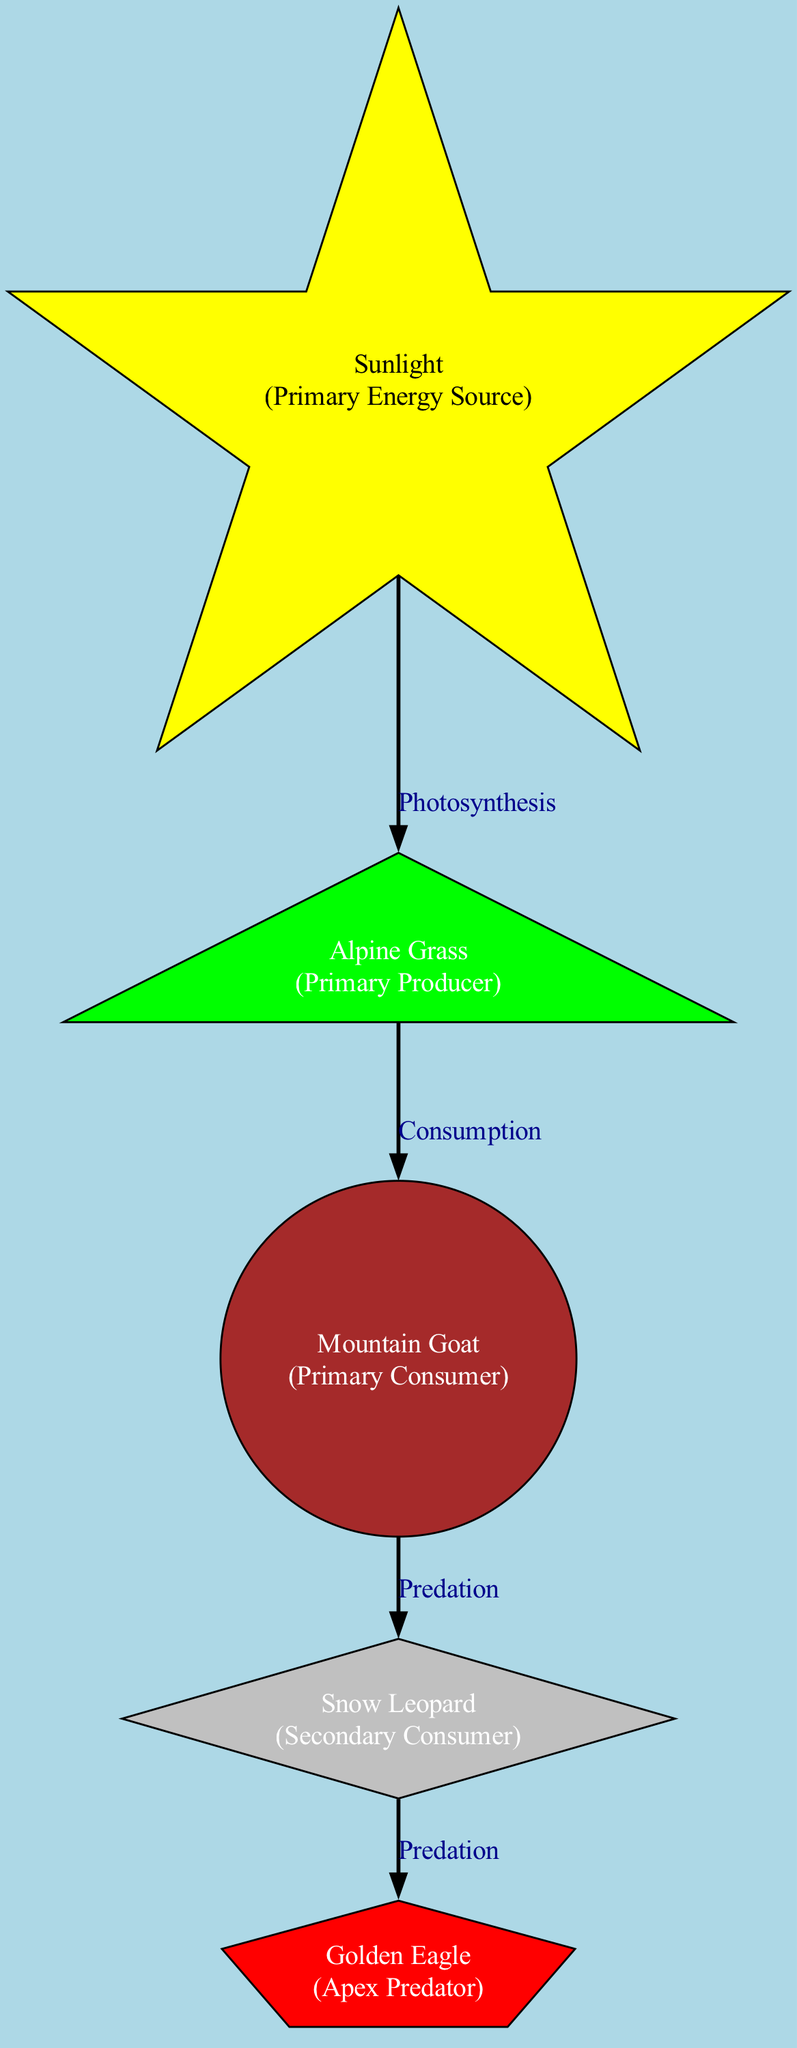What is the primary energy source in the diagram? The diagram starts with the node 'sunlight', which is described as the primary energy source. This is the first node listed in the data and directs towards the producers.
Answer: Sunlight How many nodes are present in the food chain? The food chain has five distinct nodes: 'sunlight', 'alpine_grass', 'alpine_herbivore', 'alpine_carnivore', and 'apex_predator'. By counting each node listed in the data, we confirm a total of five.
Answer: 5 What type of organism is the 'Mountain Goat' in the energy flow? 'Mountain Goat' is classified as a primary consumer in the hierarchy of the food chain based on its position after the producers and before the carnivores.
Answer: Primary Consumer What relationship is indicated by the edge connecting 'Alpine Grass' to 'Mountain Goat'? The edge between 'alpine_grass' and 'alpine_herbivore' is labeled 'Consumption', showing the relationship of the goat consuming grass, which represents the flow of energy in that direction.
Answer: Consumption Which organism is at the top of the food chain? The apex predator at the top of the food chain is represented by the 'Golden Eagle' node, which is the last in the flow of energy relationships.
Answer: Golden Eagle How many edges are present in the diagram? A count of the edges connecting the nodes shows four connections: sunlight to alpine_grass, alpine_grass to alpine_herbivore, alpine_herbivore to alpine_carnivore, and alpine_carnivore to apex_predator.
Answer: 4 What does the arrow from 'Alpine Carnivore' to 'Apex Predator' indicate? This arrow represents the relationship of 'Predation', indicating that the 'alpine_carnivore', like the snow leopard, preys on the apex predator, which is the golden eagle in this context.
Answer: Predation Which node represents a primary producer? The 'Alpine Grass' node is defined as the primary producer in the food chain, being the first level that captures energy from sunlight.
Answer: Alpine Grass What energy transfer process is occurring from 'Sunlight' to 'Alpine Grass'? The process of 'Photosynthesis' is indicated here, where sunlight energy is converted into chemical energy by the alpine grass, allowing it to grow and become a food source.
Answer: Photosynthesis 